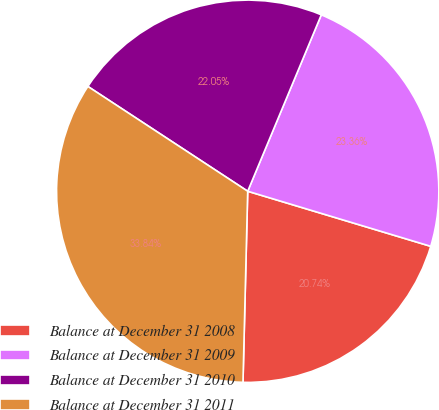Convert chart. <chart><loc_0><loc_0><loc_500><loc_500><pie_chart><fcel>Balance at December 31 2008<fcel>Balance at December 31 2009<fcel>Balance at December 31 2010<fcel>Balance at December 31 2011<nl><fcel>20.74%<fcel>23.36%<fcel>22.05%<fcel>33.84%<nl></chart> 